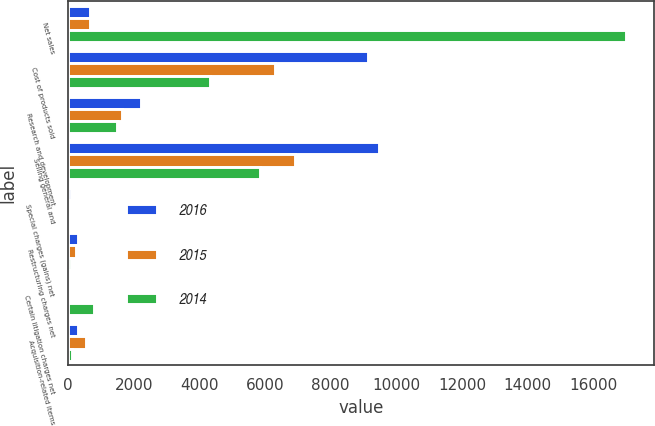<chart> <loc_0><loc_0><loc_500><loc_500><stacked_bar_chart><ecel><fcel>Net sales<fcel>Cost of products sold<fcel>Research and development<fcel>Selling general and<fcel>Special charges (gains) net<fcel>Restructuring charges net<fcel>Certain litigation charges net<fcel>Acquisition-related items<nl><fcel>2016<fcel>660<fcel>9142<fcel>2224<fcel>9469<fcel>70<fcel>290<fcel>26<fcel>283<nl><fcel>2015<fcel>660<fcel>6309<fcel>1640<fcel>6904<fcel>38<fcel>237<fcel>42<fcel>550<nl><fcel>2014<fcel>17005<fcel>4333<fcel>1477<fcel>5847<fcel>40<fcel>78<fcel>770<fcel>117<nl></chart> 